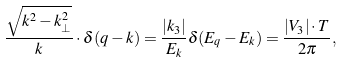Convert formula to latex. <formula><loc_0><loc_0><loc_500><loc_500>\frac { \sqrt { k ^ { 2 } - k _ { \bot } ^ { 2 } } } { k } \cdot \delta ( q - k ) = \frac { | k _ { 3 } | } { E _ { k } } \delta ( E _ { q } - E _ { k } ) = \frac { | V _ { 3 } | \cdot T } { 2 \pi } ,</formula> 